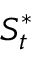<formula> <loc_0><loc_0><loc_500><loc_500>S _ { t } ^ { * }</formula> 